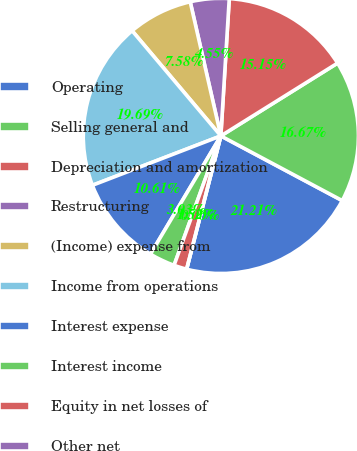Convert chart to OTSL. <chart><loc_0><loc_0><loc_500><loc_500><pie_chart><fcel>Operating<fcel>Selling general and<fcel>Depreciation and amortization<fcel>Restructuring<fcel>(Income) expense from<fcel>Income from operations<fcel>Interest expense<fcel>Interest income<fcel>Equity in net losses of<fcel>Other net<nl><fcel>21.21%<fcel>16.67%<fcel>15.15%<fcel>4.55%<fcel>7.58%<fcel>19.69%<fcel>10.61%<fcel>3.03%<fcel>1.52%<fcel>0.0%<nl></chart> 